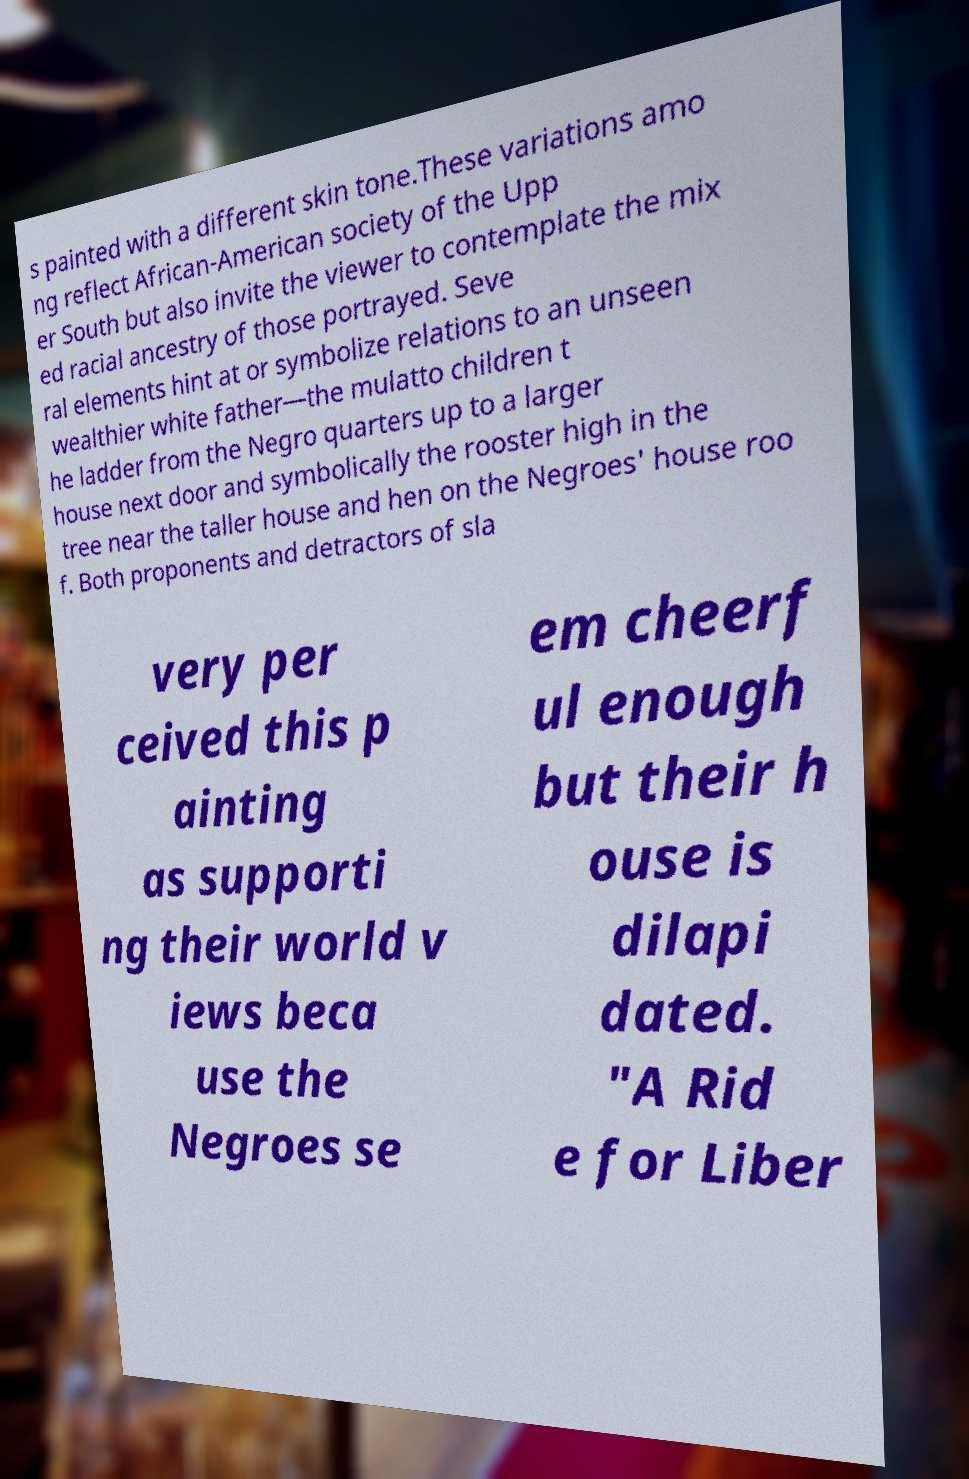Can you accurately transcribe the text from the provided image for me? s painted with a different skin tone.These variations amo ng reflect African-American society of the Upp er South but also invite the viewer to contemplate the mix ed racial ancestry of those portrayed. Seve ral elements hint at or symbolize relations to an unseen wealthier white father—the mulatto children t he ladder from the Negro quarters up to a larger house next door and symbolically the rooster high in the tree near the taller house and hen on the Negroes' house roo f. Both proponents and detractors of sla very per ceived this p ainting as supporti ng their world v iews beca use the Negroes se em cheerf ul enough but their h ouse is dilapi dated. "A Rid e for Liber 